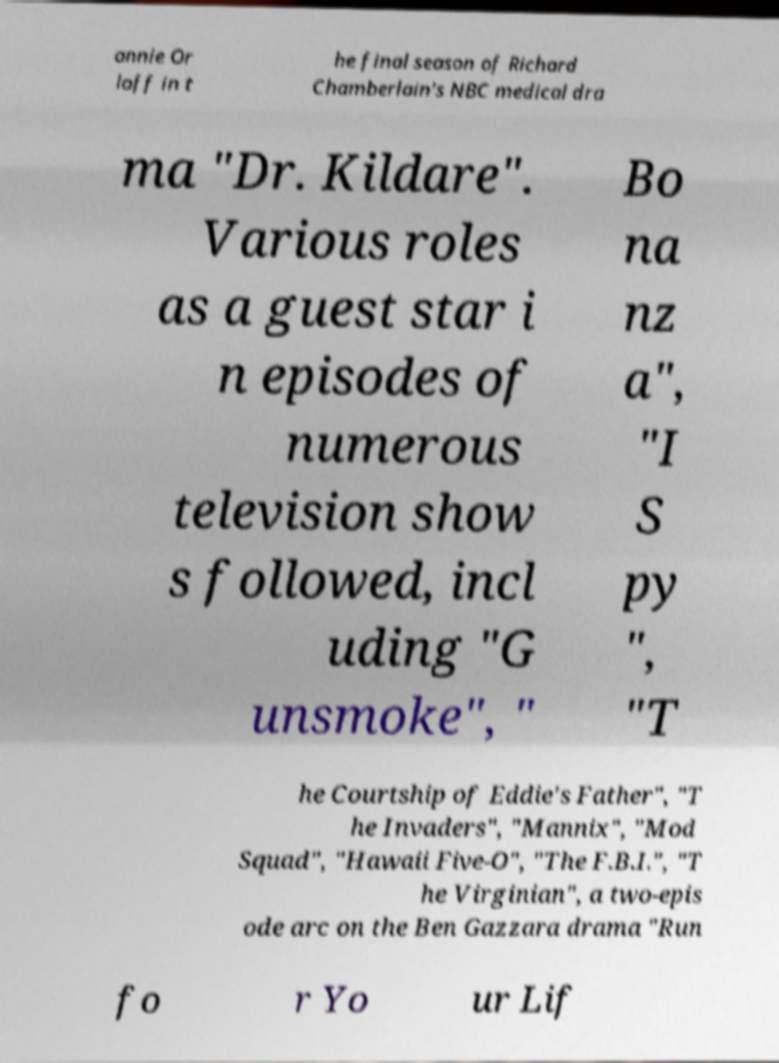Could you assist in decoding the text presented in this image and type it out clearly? annie Or loff in t he final season of Richard Chamberlain's NBC medical dra ma "Dr. Kildare". Various roles as a guest star i n episodes of numerous television show s followed, incl uding "G unsmoke", " Bo na nz a", "I S py ", "T he Courtship of Eddie's Father", "T he Invaders", "Mannix", "Mod Squad", "Hawaii Five-O", "The F.B.I.", "T he Virginian", a two-epis ode arc on the Ben Gazzara drama "Run fo r Yo ur Lif 